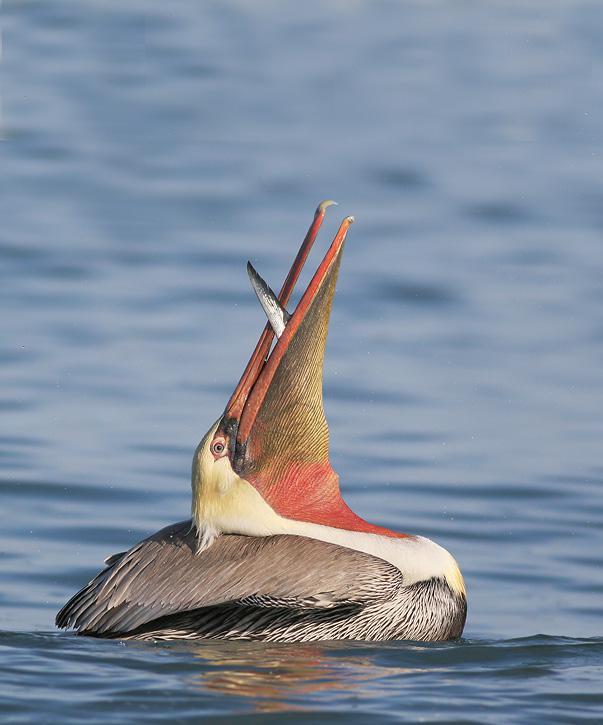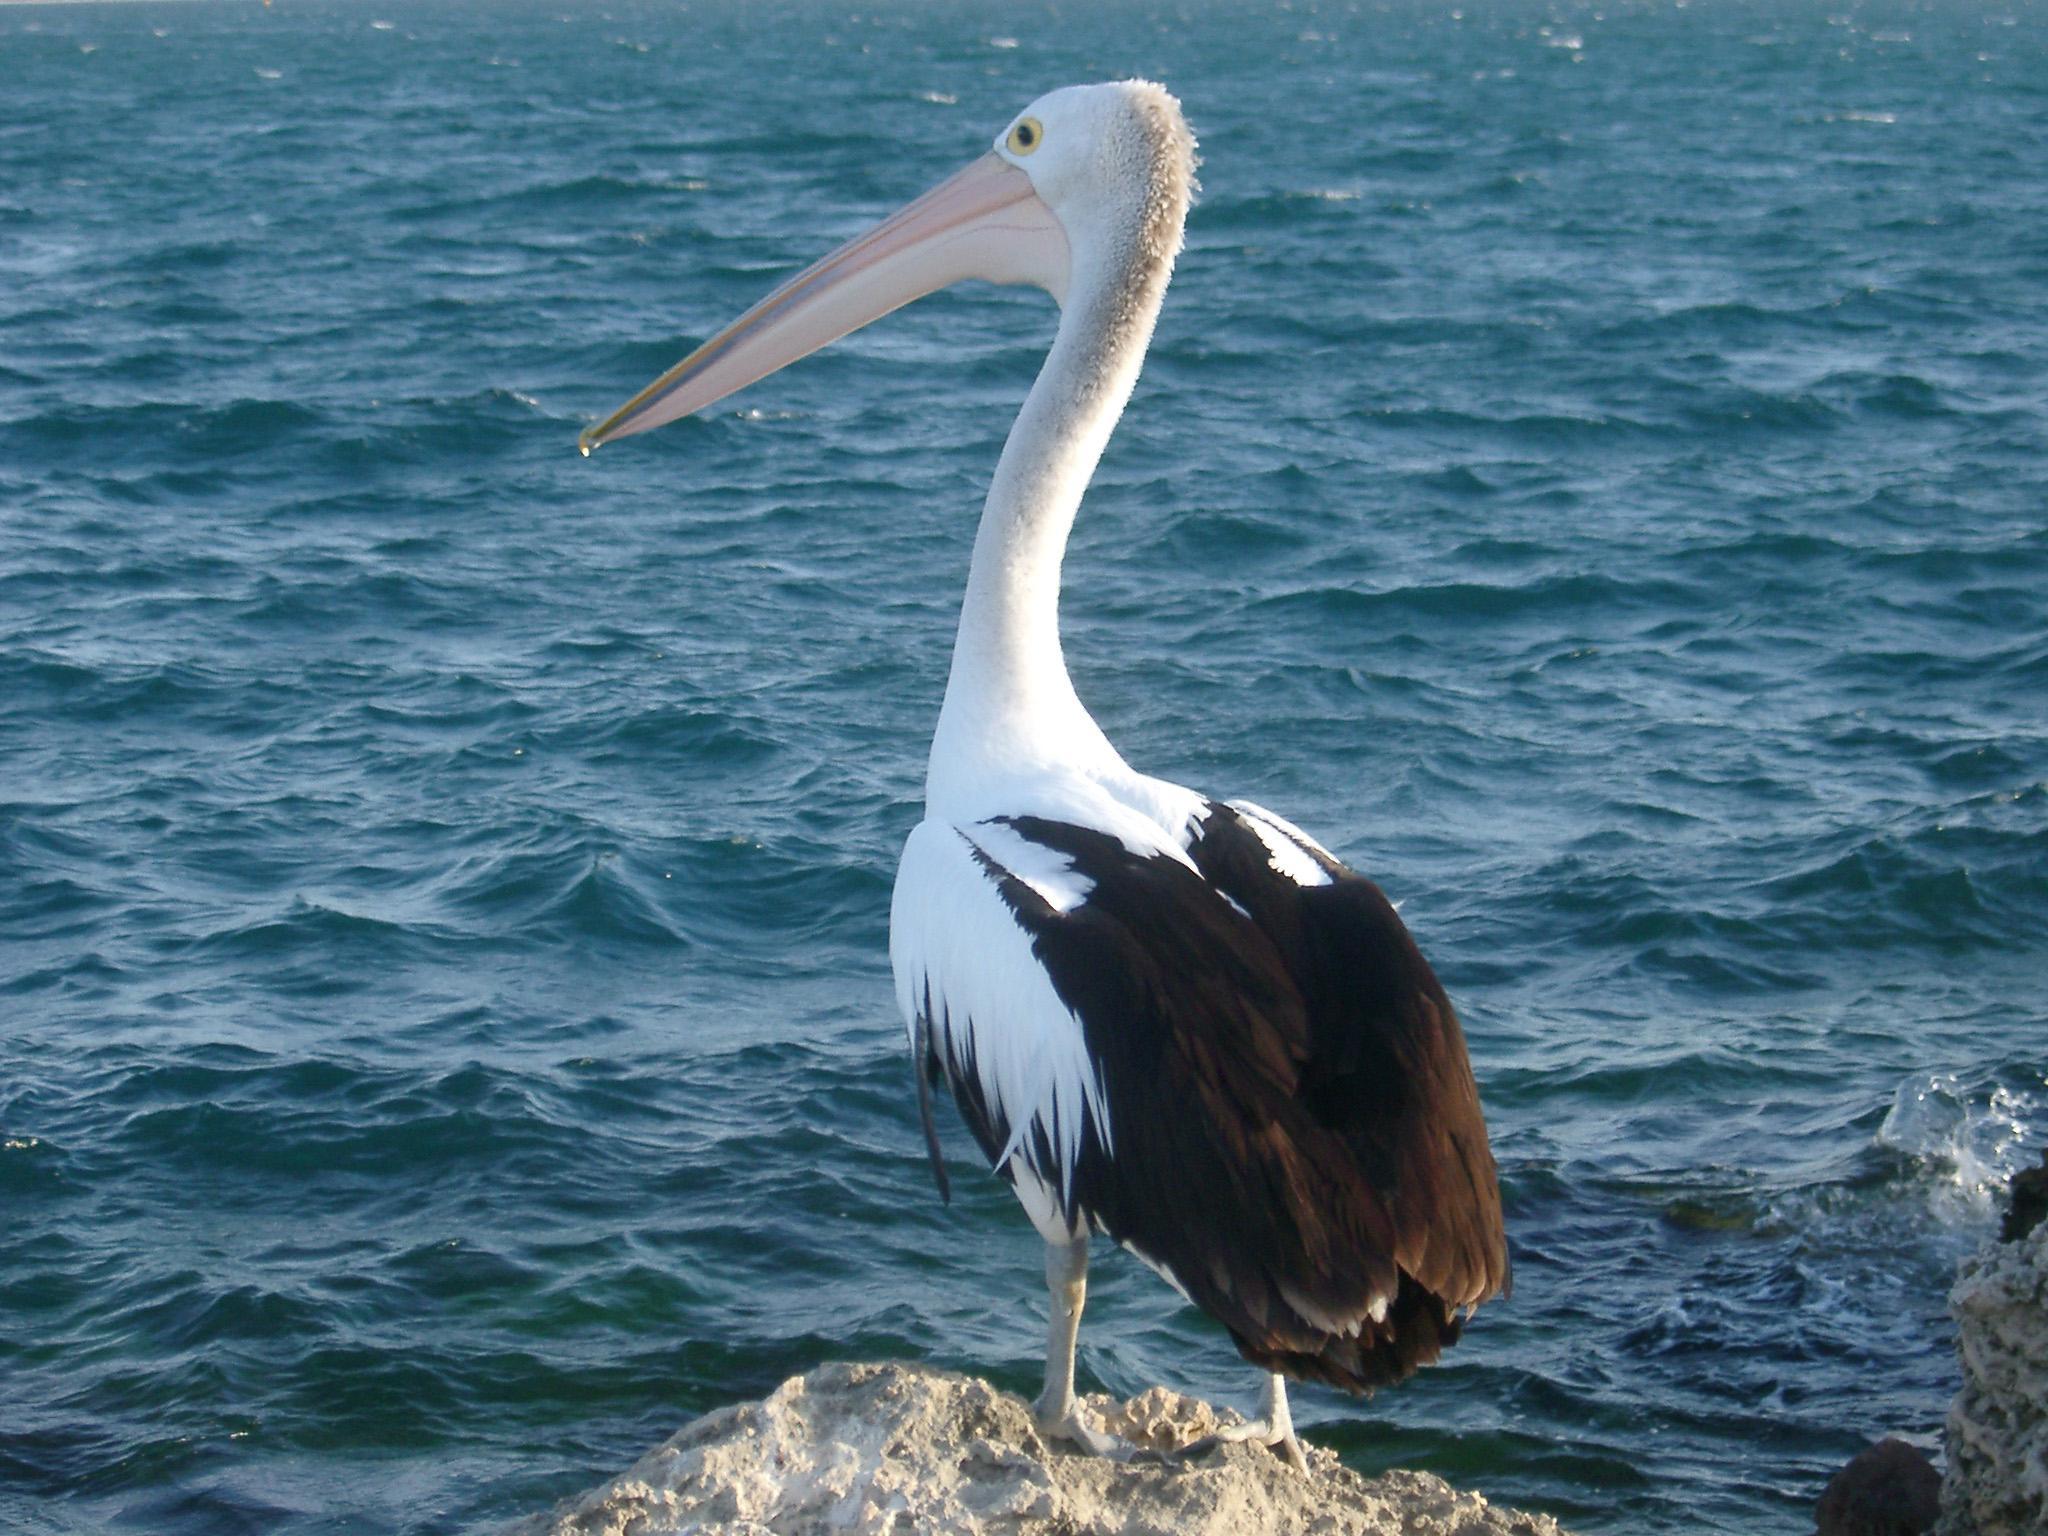The first image is the image on the left, the second image is the image on the right. For the images displayed, is the sentence "All of the birds are facing the right." factually correct? Answer yes or no. No. 